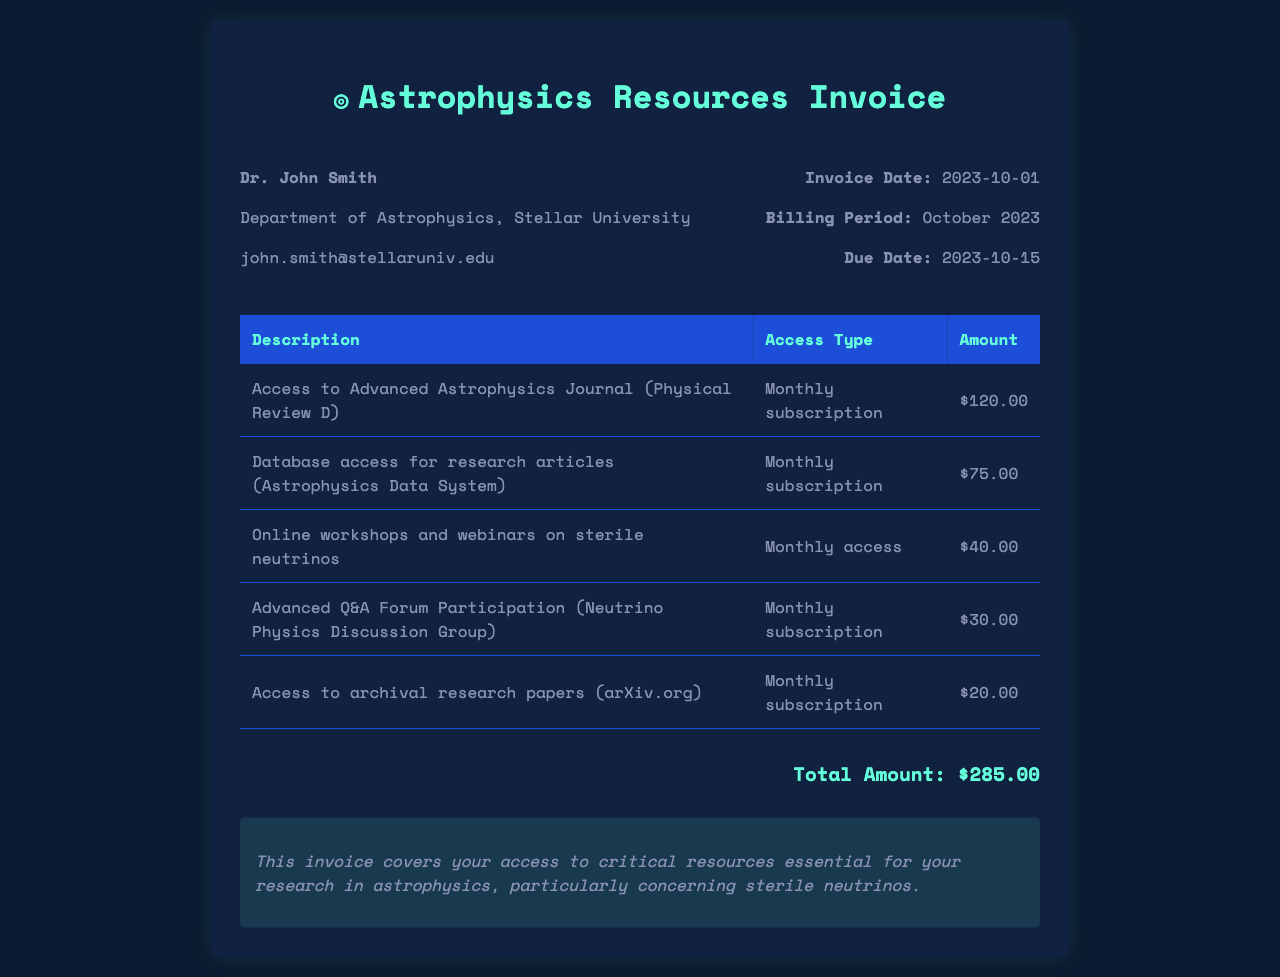What is the total amount due? The total amount due is stated at the bottom of the invoice and is the sum of all item amounts.
Answer: $285.00 Who is the subscriber? The subscriber's name is listed at the top of the invoice, providing the identity of the individual receiving the invoice.
Answer: Dr. John Smith What is the billing period for this invoice? The billing period is indicated within the invoice details, representing the timeframe of service provided.
Answer: October 2023 How many online workshops are included in the subscription? The invoice lists one entry for online workshops and webinars specifically related to sterile neutrinos.
Answer: One What are the access types for the Advanced Astrophysics Journal? Each listed service has a specified access type, which indicates the nature of the subscription.
Answer: Monthly subscription What is the due date for payment? The due date is important to know for preventing late fees and ensuring continued access to services.
Answer: 2023-10-15 How much does the access to archival research papers cost? The cost is specified in the itemized list, allowing for quick reference when assessing total expenses.
Answer: $20.00 What is included in the notes section of the invoice? The notes section often provides important information regarding the invoice’s purpose and the resources covered.
Answer: Critical resources essential for your research in astrophysics, particularly concerning sterile neutrinos 